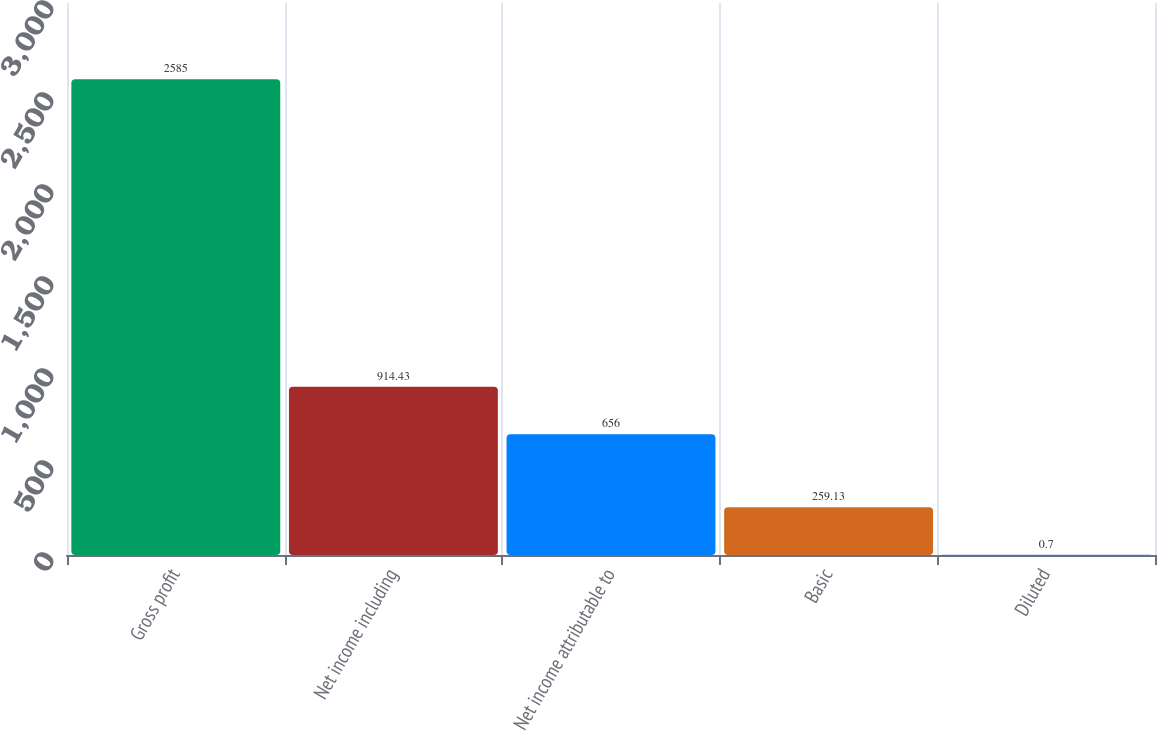Convert chart to OTSL. <chart><loc_0><loc_0><loc_500><loc_500><bar_chart><fcel>Gross profit<fcel>Net income including<fcel>Net income attributable to<fcel>Basic<fcel>Diluted<nl><fcel>2585<fcel>914.43<fcel>656<fcel>259.13<fcel>0.7<nl></chart> 